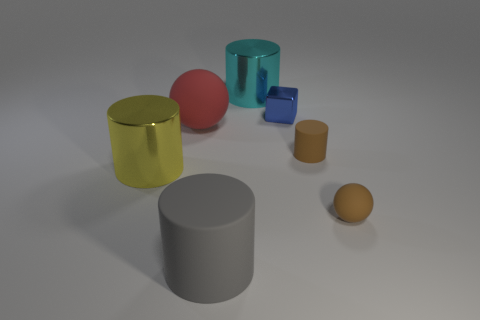Subtract 1 cylinders. How many cylinders are left? 3 Subtract all green cylinders. Subtract all brown balls. How many cylinders are left? 4 Add 1 small yellow rubber blocks. How many objects exist? 8 Subtract all cylinders. How many objects are left? 3 Subtract 0 yellow cubes. How many objects are left? 7 Subtract all tiny blue objects. Subtract all red spheres. How many objects are left? 5 Add 3 cubes. How many cubes are left? 4 Add 7 brown spheres. How many brown spheres exist? 8 